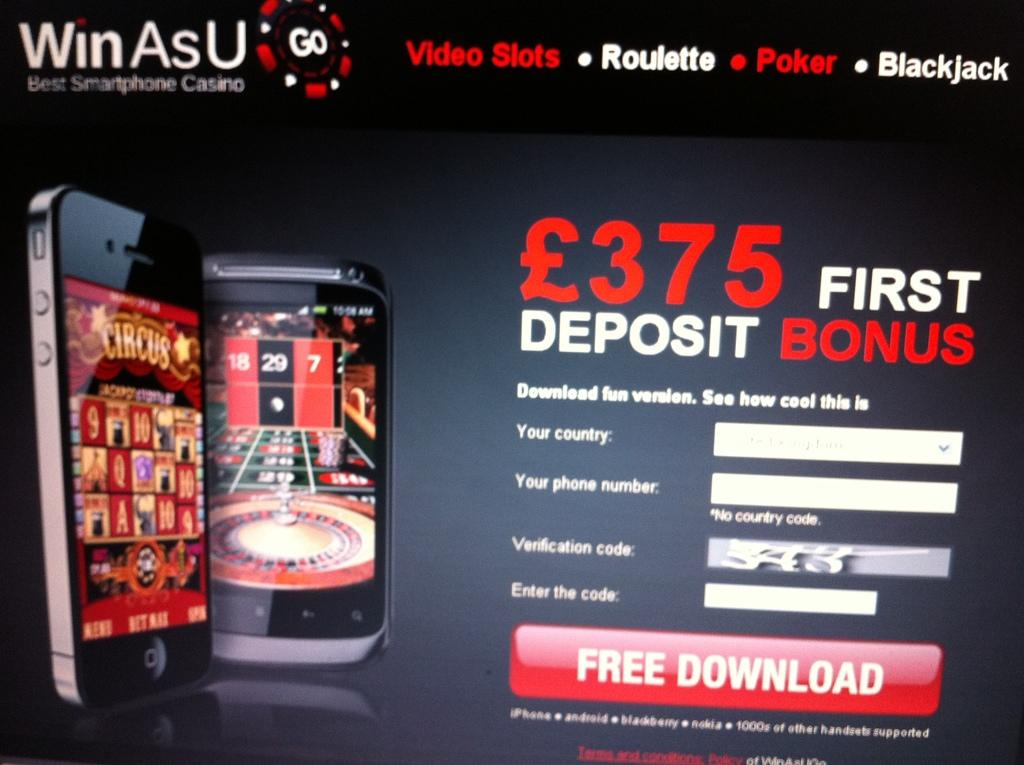<image>
Provide a brief description of the given image. A program, called Win AsU, advertises a 375 first deposit bonus. 